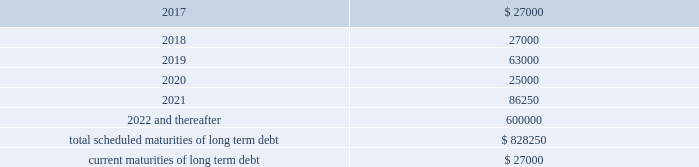Be adjusted by reference to a grid ( the 201cpricing grid 201d ) based on the consolidated leverage ratio and ranges between 1.00% ( 1.00 % ) to 1.25% ( 1.25 % ) for adjusted libor loans and 0.00% ( 0.00 % ) to 0.25% ( 0.25 % ) for alternate base rate loans .
The weighted average interest rate under the outstanding term loans and revolving credit facility borrowings was 1.6% ( 1.6 % ) and 1.3% ( 1.3 % ) during the years ended december 31 , 2016 and 2015 , respectively .
The company pays a commitment fee on the average daily unused amount of the revolving credit facility and certain fees with respect to letters of credit .
As of december 31 , 2016 , the commitment fee was 15.0 basis points .
Since inception , the company incurred and deferred $ 3.9 million in financing costs in connection with the credit agreement .
3.250% ( 3.250 % ) senior notes in june 2016 , the company issued $ 600.0 million aggregate principal amount of 3.250% ( 3.250 % ) senior unsecured notes due june 15 , 2026 ( the 201cnotes 201d ) .
The proceeds were used to pay down amounts outstanding under the revolving credit facility .
Interest is payable semi-annually on june 15 and december 15 beginning december 15 , 2016 .
Prior to march 15 , 2026 ( three months prior to the maturity date of the notes ) , the company may redeem some or all of the notes at any time or from time to time at a redemption price equal to the greater of 100% ( 100 % ) of the principal amount of the notes to be redeemed or a 201cmake-whole 201d amount applicable to such notes as described in the indenture governing the notes , plus accrued and unpaid interest to , but excluding , the redemption date .
On or after march 15 , 2026 ( three months prior to the maturity date of the notes ) , the company may redeem some or all of the notes at any time or from time to time at a redemption price equal to 100% ( 100 % ) of the principal amount of the notes to be redeemed , plus accrued and unpaid interest to , but excluding , the redemption date .
The indenture governing the notes contains covenants , including limitations that restrict the company 2019s ability and the ability of certain of its subsidiaries to create or incur secured indebtedness and enter into sale and leaseback transactions and the company 2019s ability to consolidate , merge or transfer all or substantially all of its properties or assets to another person , in each case subject to material exceptions described in the indenture .
The company incurred and deferred $ 5.3 million in financing costs in connection with the notes .
Other long term debt in december 2012 , the company entered into a $ 50.0 million recourse loan collateralized by the land , buildings and tenant improvements comprising the company 2019s corporate headquarters .
The loan has a seven year term and maturity date of december 2019 .
The loan bears interest at one month libor plus a margin of 1.50% ( 1.50 % ) , and allows for prepayment without penalty .
The loan includes covenants and events of default substantially consistent with the company 2019s credit agreement discussed above .
The loan also requires prior approval of the lender for certain matters related to the property , including transfers of any interest in the property .
As of december 31 , 2016 and 2015 , the outstanding balance on the loan was $ 42.0 million and $ 44.0 million , respectively .
The weighted average interest rate on the loan was 2.0% ( 2.0 % ) and 1.7% ( 1.7 % ) for the years ended december 31 , 2016 and 2015 , respectively .
The following are the scheduled maturities of long term debt as of december 31 , 2016 : ( in thousands ) .

What portion of the total long term debt is due in the next 12 months? 
Computations: (27000 / 828250)
Answer: 0.0326. 